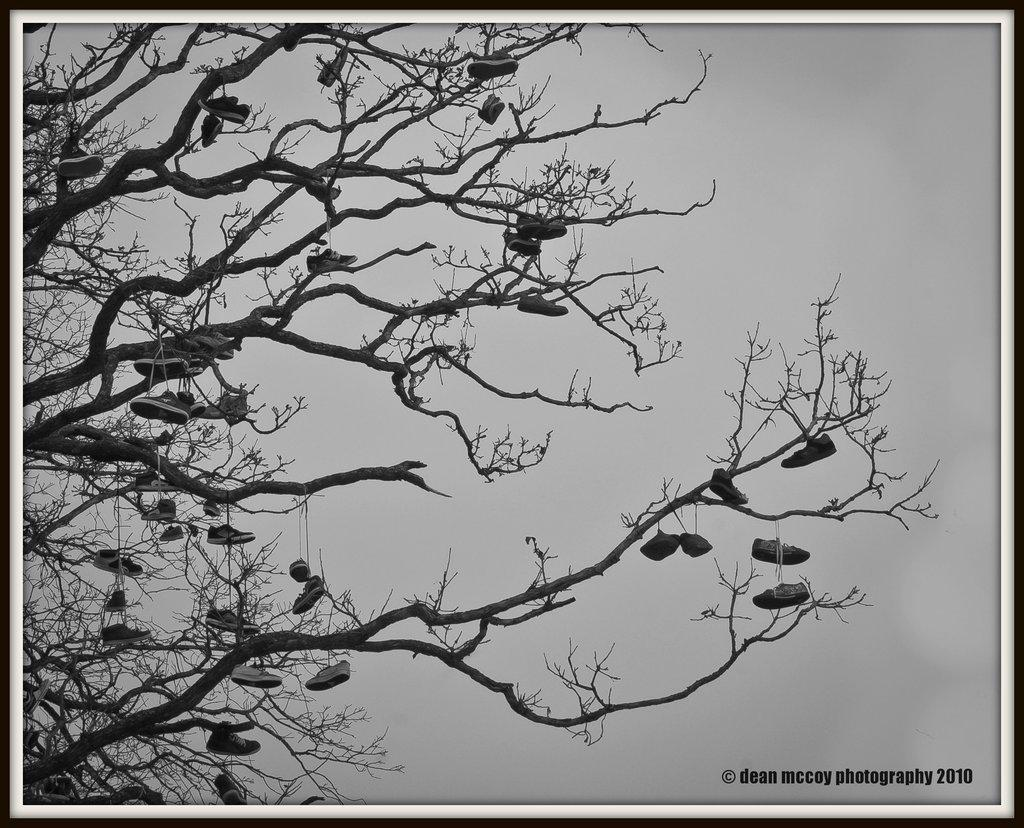What is the main subject of the image? There is a photo in the image. What can be seen in the background of the photo? The sky is visible in the image. What unusual object is hanging on the tree in the image? There are shoes hung on a tree in the image. Where is the text located in the image? The text is at the bottom right of the image. How many boats are visible in the image? There are no boats present in the image. What type of cannon is being fired in the image? There is no cannon or any indication of firing in the image. 